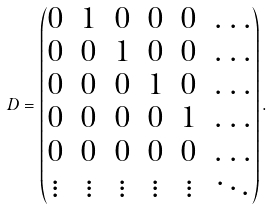Convert formula to latex. <formula><loc_0><loc_0><loc_500><loc_500>D = \begin{pmatrix} 0 & 1 & 0 & 0 & 0 & \dots \\ 0 & 0 & 1 & 0 & 0 & \dots \\ 0 & 0 & 0 & 1 & 0 & \dots \\ 0 & 0 & 0 & 0 & 1 & \dots \\ 0 & 0 & 0 & 0 & 0 & \dots \\ \vdots & \vdots & \vdots & \vdots & \vdots & \ddots \end{pmatrix} .</formula> 